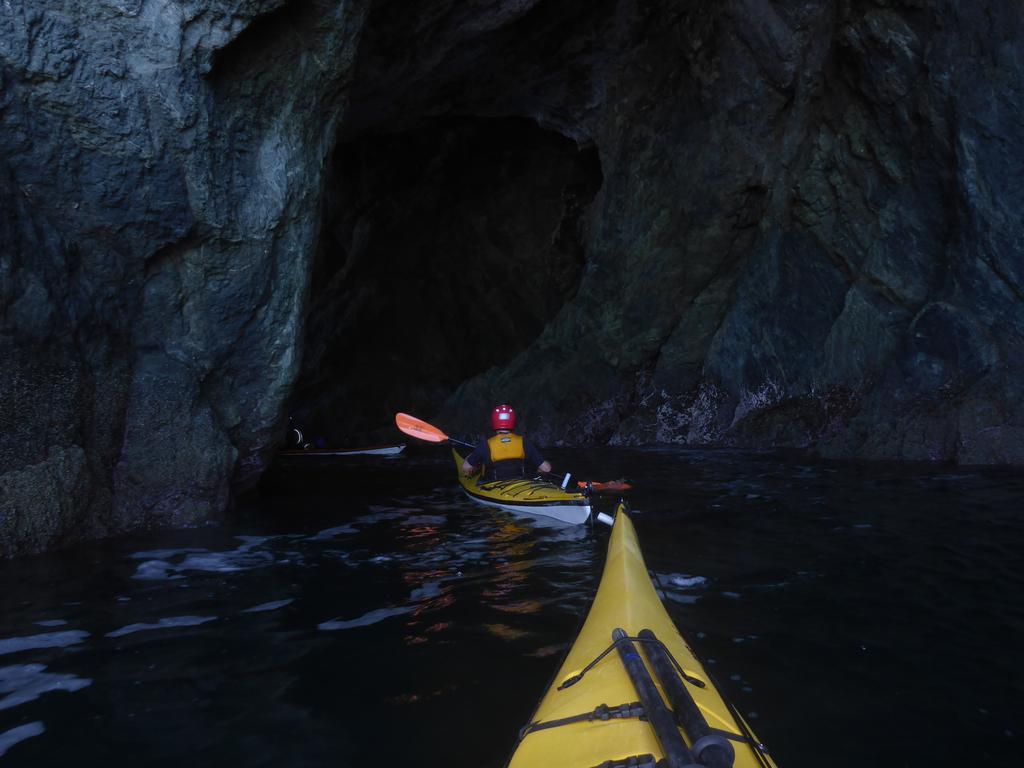Describe this image in one or two sentences. Here we can see a kayak on the water. In the background there are two persons sitting on the kayak on the water and we can see a paddle and this looks like a cave with big rocks above them. 